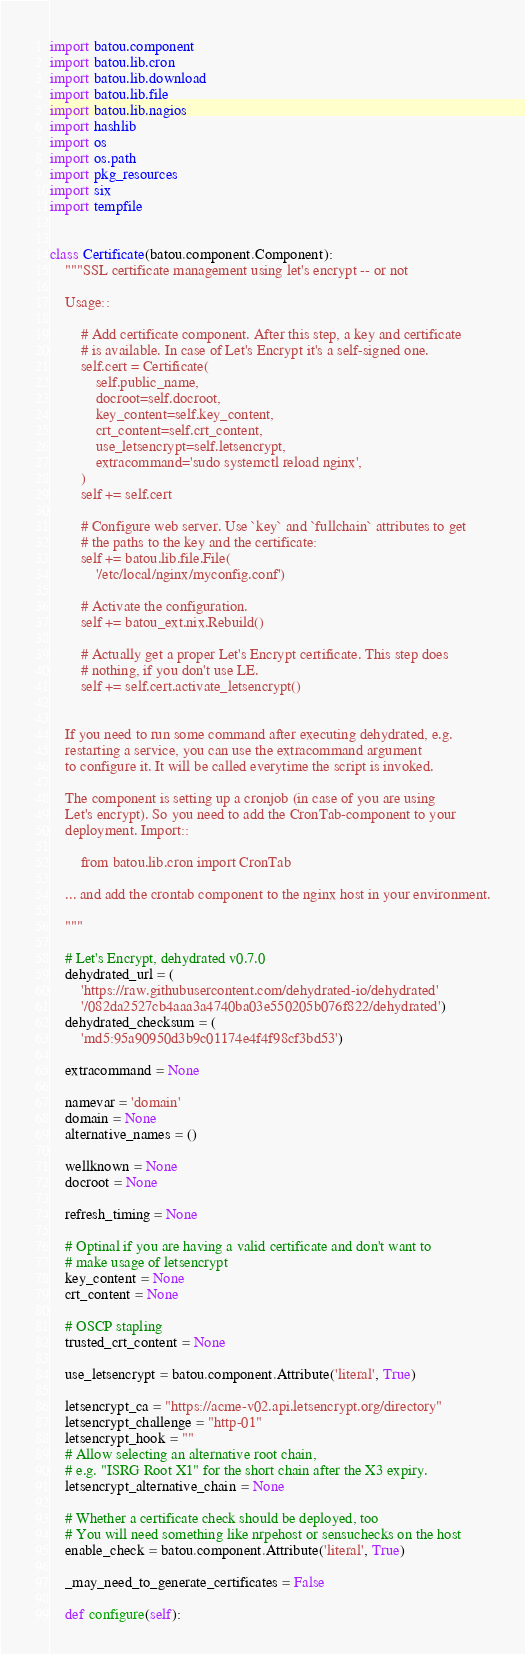<code> <loc_0><loc_0><loc_500><loc_500><_Python_>import batou.component
import batou.lib.cron
import batou.lib.download
import batou.lib.file
import batou.lib.nagios
import hashlib
import os
import os.path
import pkg_resources
import six
import tempfile


class Certificate(batou.component.Component):
    """SSL certificate management using let's encrypt -- or not

    Usage::

        # Add certificate component. After this step, a key and certificate
        # is available. In case of Let's Encrypt it's a self-signed one.
        self.cert = Certificate(
            self.public_name,
            docroot=self.docroot,
            key_content=self.key_content,
            crt_content=self.crt_content,
            use_letsencrypt=self.letsencrypt,
            extracommand='sudo systemctl reload nginx',
        )
        self += self.cert

        # Configure web server. Use `key` and `fullchain` attributes to get
        # the paths to the key and the certificate:
        self += batou.lib.file.File(
            '/etc/local/nginx/myconfig.conf')

        # Activate the configuration.
        self += batou_ext.nix.Rebuild()

        # Actually get a proper Let's Encrypt certificate. This step does
        # nothing, if you don't use LE.
        self += self.cert.activate_letsencrypt()


    If you need to run some command after executing dehydrated, e.g.
    restarting a service, you can use the extracommand argument
    to configure it. It will be called everytime the script is invoked.

    The component is setting up a cronjob (in case of you are using
    Let's encrypt). So you need to add the CronTab-component to your
    deployment. Import::

        from batou.lib.cron import CronTab

    ... and add the crontab component to the nginx host in your environment.

    """

    # Let's Encrypt, dehydrated v0.7.0
    dehydrated_url = (
        'https://raw.githubusercontent.com/dehydrated-io/dehydrated'
        '/082da2527cb4aaa3a4740ba03e550205b076f822/dehydrated')
    dehydrated_checksum = (
        'md5:95a90950d3b9c01174e4f4f98cf3bd53')

    extracommand = None

    namevar = 'domain'
    domain = None
    alternative_names = ()

    wellknown = None
    docroot = None

    refresh_timing = None

    # Optinal if you are having a valid certificate and don't want to
    # make usage of letsencrypt
    key_content = None
    crt_content = None

    # OSCP stapling
    trusted_crt_content = None

    use_letsencrypt = batou.component.Attribute('literal', True)

    letsencrypt_ca = "https://acme-v02.api.letsencrypt.org/directory"
    letsencrypt_challenge = "http-01"
    letsencrypt_hook = ""
    # Allow selecting an alternative root chain,
    # e.g. "ISRG Root X1" for the short chain after the X3 expiry.
    letsencrypt_alternative_chain = None

    # Whether a certificate check should be deployed, too
    # You will need something like nrpehost or sensuchecks on the host
    enable_check = batou.component.Attribute('literal', True)

    _may_need_to_generate_certificates = False

    def configure(self):</code> 